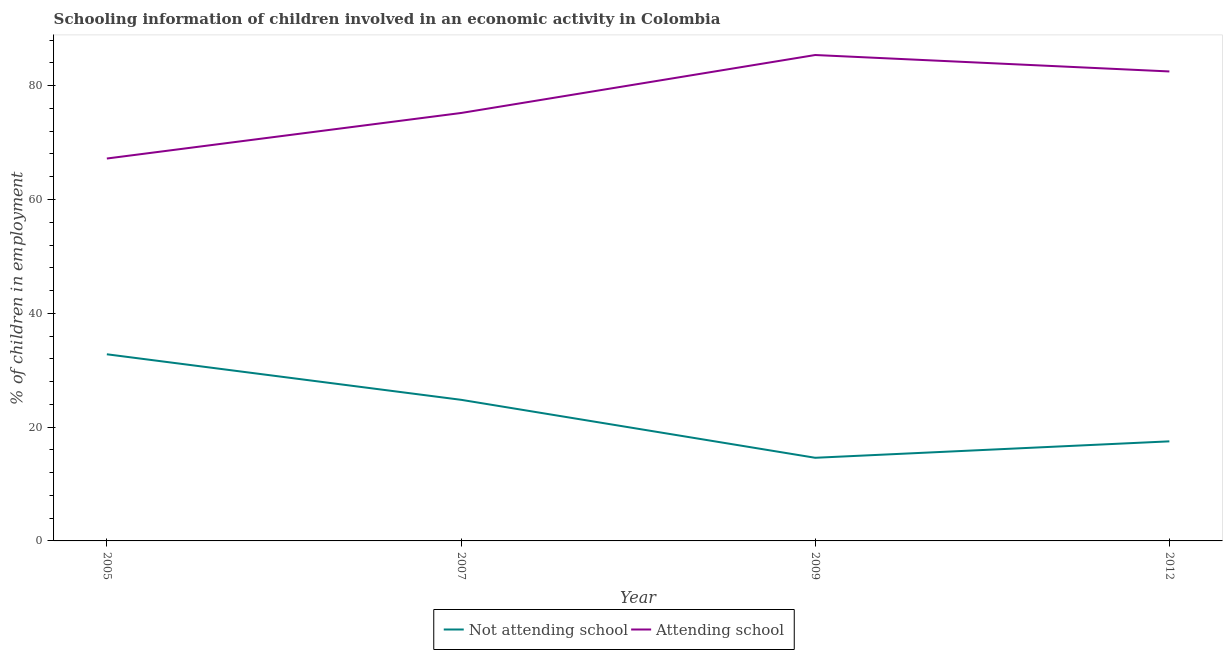Is the number of lines equal to the number of legend labels?
Keep it short and to the point. Yes. What is the percentage of employed children who are attending school in 2007?
Give a very brief answer. 75.2. Across all years, what is the maximum percentage of employed children who are attending school?
Ensure brevity in your answer.  85.39. Across all years, what is the minimum percentage of employed children who are not attending school?
Make the answer very short. 14.61. In which year was the percentage of employed children who are attending school minimum?
Provide a short and direct response. 2005. What is the total percentage of employed children who are not attending school in the graph?
Provide a short and direct response. 89.71. What is the difference between the percentage of employed children who are attending school in 2007 and that in 2012?
Provide a short and direct response. -7.3. What is the difference between the percentage of employed children who are not attending school in 2009 and the percentage of employed children who are attending school in 2012?
Make the answer very short. -67.89. What is the average percentage of employed children who are not attending school per year?
Give a very brief answer. 22.43. In the year 2009, what is the difference between the percentage of employed children who are attending school and percentage of employed children who are not attending school?
Offer a very short reply. 70.78. In how many years, is the percentage of employed children who are attending school greater than 16 %?
Ensure brevity in your answer.  4. What is the ratio of the percentage of employed children who are not attending school in 2005 to that in 2007?
Provide a short and direct response. 1.32. Is the difference between the percentage of employed children who are attending school in 2007 and 2009 greater than the difference between the percentage of employed children who are not attending school in 2007 and 2009?
Provide a succinct answer. No. What is the difference between the highest and the second highest percentage of employed children who are attending school?
Offer a terse response. 2.89. What is the difference between the highest and the lowest percentage of employed children who are not attending school?
Your answer should be very brief. 18.19. How many years are there in the graph?
Your response must be concise. 4. What is the difference between two consecutive major ticks on the Y-axis?
Your answer should be compact. 20. How many legend labels are there?
Ensure brevity in your answer.  2. What is the title of the graph?
Provide a short and direct response. Schooling information of children involved in an economic activity in Colombia. Does "Rural Population" appear as one of the legend labels in the graph?
Your answer should be very brief. No. What is the label or title of the X-axis?
Your response must be concise. Year. What is the label or title of the Y-axis?
Ensure brevity in your answer.  % of children in employment. What is the % of children in employment in Not attending school in 2005?
Your answer should be very brief. 32.8. What is the % of children in employment of Attending school in 2005?
Offer a very short reply. 67.2. What is the % of children in employment in Not attending school in 2007?
Provide a succinct answer. 24.8. What is the % of children in employment of Attending school in 2007?
Give a very brief answer. 75.2. What is the % of children in employment in Not attending school in 2009?
Provide a short and direct response. 14.61. What is the % of children in employment of Attending school in 2009?
Offer a very short reply. 85.39. What is the % of children in employment in Attending school in 2012?
Offer a very short reply. 82.5. Across all years, what is the maximum % of children in employment of Not attending school?
Provide a short and direct response. 32.8. Across all years, what is the maximum % of children in employment of Attending school?
Make the answer very short. 85.39. Across all years, what is the minimum % of children in employment in Not attending school?
Your response must be concise. 14.61. Across all years, what is the minimum % of children in employment of Attending school?
Ensure brevity in your answer.  67.2. What is the total % of children in employment of Not attending school in the graph?
Give a very brief answer. 89.71. What is the total % of children in employment of Attending school in the graph?
Your response must be concise. 310.29. What is the difference between the % of children in employment in Attending school in 2005 and that in 2007?
Keep it short and to the point. -8. What is the difference between the % of children in employment in Not attending school in 2005 and that in 2009?
Your answer should be very brief. 18.19. What is the difference between the % of children in employment in Attending school in 2005 and that in 2009?
Your response must be concise. -18.19. What is the difference between the % of children in employment in Attending school in 2005 and that in 2012?
Give a very brief answer. -15.3. What is the difference between the % of children in employment of Not attending school in 2007 and that in 2009?
Your answer should be compact. 10.19. What is the difference between the % of children in employment of Attending school in 2007 and that in 2009?
Keep it short and to the point. -10.19. What is the difference between the % of children in employment in Attending school in 2007 and that in 2012?
Your response must be concise. -7.3. What is the difference between the % of children in employment in Not attending school in 2009 and that in 2012?
Offer a terse response. -2.89. What is the difference between the % of children in employment in Attending school in 2009 and that in 2012?
Make the answer very short. 2.89. What is the difference between the % of children in employment of Not attending school in 2005 and the % of children in employment of Attending school in 2007?
Make the answer very short. -42.4. What is the difference between the % of children in employment in Not attending school in 2005 and the % of children in employment in Attending school in 2009?
Make the answer very short. -52.59. What is the difference between the % of children in employment in Not attending school in 2005 and the % of children in employment in Attending school in 2012?
Your answer should be very brief. -49.7. What is the difference between the % of children in employment in Not attending school in 2007 and the % of children in employment in Attending school in 2009?
Your answer should be compact. -60.59. What is the difference between the % of children in employment in Not attending school in 2007 and the % of children in employment in Attending school in 2012?
Offer a terse response. -57.7. What is the difference between the % of children in employment in Not attending school in 2009 and the % of children in employment in Attending school in 2012?
Keep it short and to the point. -67.89. What is the average % of children in employment of Not attending school per year?
Your answer should be compact. 22.43. What is the average % of children in employment in Attending school per year?
Provide a succinct answer. 77.57. In the year 2005, what is the difference between the % of children in employment of Not attending school and % of children in employment of Attending school?
Keep it short and to the point. -34.4. In the year 2007, what is the difference between the % of children in employment in Not attending school and % of children in employment in Attending school?
Your response must be concise. -50.4. In the year 2009, what is the difference between the % of children in employment in Not attending school and % of children in employment in Attending school?
Your answer should be very brief. -70.78. In the year 2012, what is the difference between the % of children in employment in Not attending school and % of children in employment in Attending school?
Ensure brevity in your answer.  -65. What is the ratio of the % of children in employment of Not attending school in 2005 to that in 2007?
Provide a short and direct response. 1.32. What is the ratio of the % of children in employment in Attending school in 2005 to that in 2007?
Provide a short and direct response. 0.89. What is the ratio of the % of children in employment of Not attending school in 2005 to that in 2009?
Provide a short and direct response. 2.25. What is the ratio of the % of children in employment in Attending school in 2005 to that in 2009?
Provide a short and direct response. 0.79. What is the ratio of the % of children in employment in Not attending school in 2005 to that in 2012?
Ensure brevity in your answer.  1.87. What is the ratio of the % of children in employment of Attending school in 2005 to that in 2012?
Your response must be concise. 0.81. What is the ratio of the % of children in employment in Not attending school in 2007 to that in 2009?
Ensure brevity in your answer.  1.7. What is the ratio of the % of children in employment of Attending school in 2007 to that in 2009?
Give a very brief answer. 0.88. What is the ratio of the % of children in employment of Not attending school in 2007 to that in 2012?
Give a very brief answer. 1.42. What is the ratio of the % of children in employment of Attending school in 2007 to that in 2012?
Make the answer very short. 0.91. What is the ratio of the % of children in employment in Not attending school in 2009 to that in 2012?
Your answer should be very brief. 0.83. What is the ratio of the % of children in employment of Attending school in 2009 to that in 2012?
Keep it short and to the point. 1.03. What is the difference between the highest and the second highest % of children in employment in Attending school?
Offer a terse response. 2.89. What is the difference between the highest and the lowest % of children in employment in Not attending school?
Ensure brevity in your answer.  18.19. What is the difference between the highest and the lowest % of children in employment in Attending school?
Offer a terse response. 18.19. 